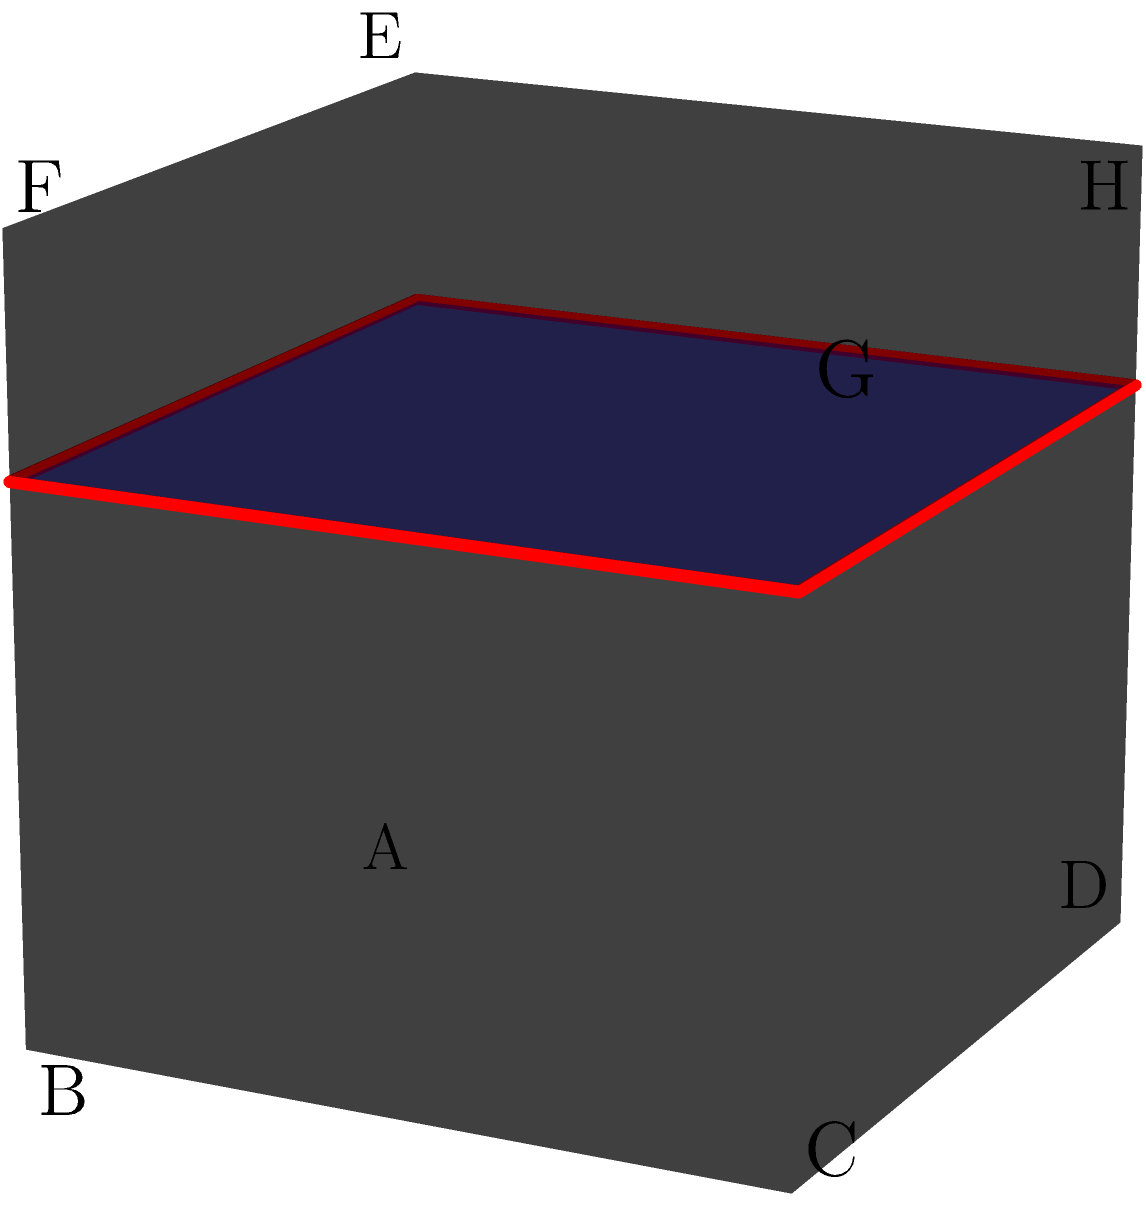A unit cube ABCDEFGH is intersected by a plane parallel to the base at a height of 0.7 units from the base. Without compromising your privacy, determine the shape and dimensions of the resulting cross-section. To solve this problem, let's follow these steps:

1. Visualize the cube: The cube has a side length of 1 unit.

2. Understand the cutting plane: The plane is parallel to the base (ABCD) and is 0.7 units above it.

3. Determine the shape of the cross-section:
   - Since the cutting plane is parallel to the base, the cross-section will have the same shape as the base.
   - The base of a cube is a square, so the cross-section will also be a square.

4. Calculate the dimensions of the cross-section:
   - The cutting plane intersects all four vertical edges of the cube at the same height (0.7 units).
   - The cross-section is a scaled-down version of the base.
   - The scale factor is the same as the height of the cutting plane: 0.7

5. Determine the side length of the cross-section:
   - Original side length of the cube: 1 unit
   - Scale factor: 0.7
   - Side length of the cross-section = $1 \times 0.7 = 0.7$ units

Therefore, the cross-section is a square with side length 0.7 units.
Answer: Square with side length 0.7 units 